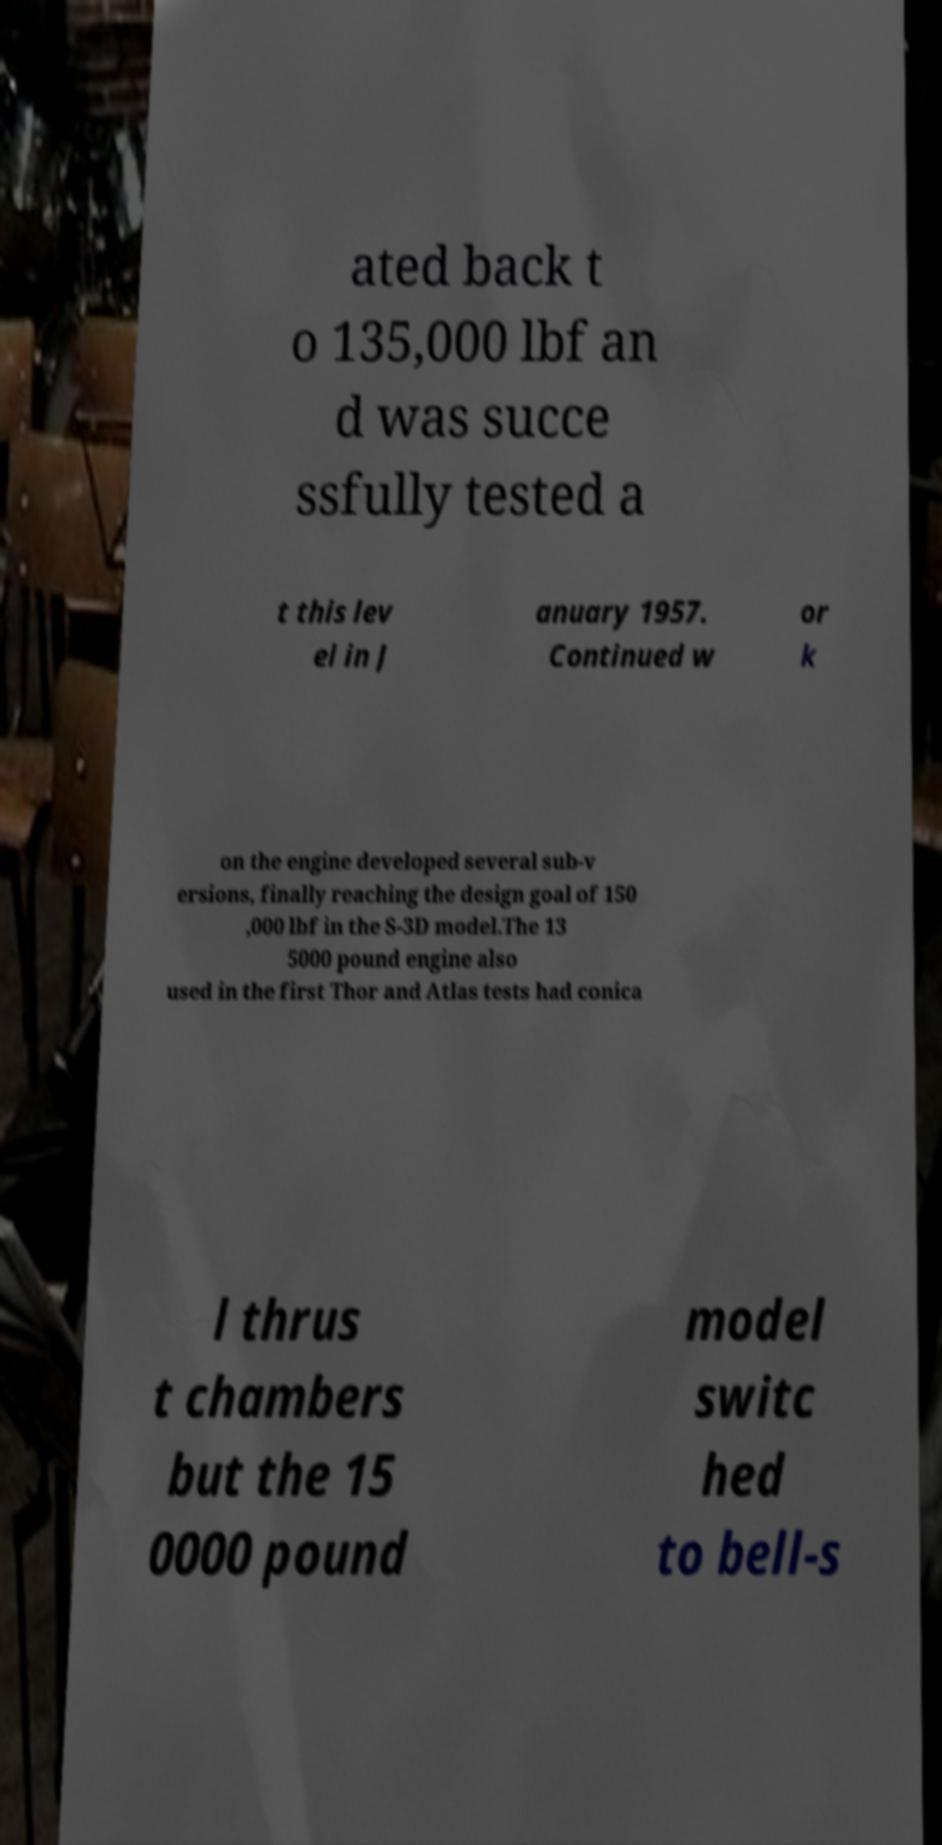I need the written content from this picture converted into text. Can you do that? ated back t o 135,000 lbf an d was succe ssfully tested a t this lev el in J anuary 1957. Continued w or k on the engine developed several sub-v ersions, finally reaching the design goal of 150 ,000 lbf in the S-3D model.The 13 5000 pound engine also used in the first Thor and Atlas tests had conica l thrus t chambers but the 15 0000 pound model switc hed to bell-s 